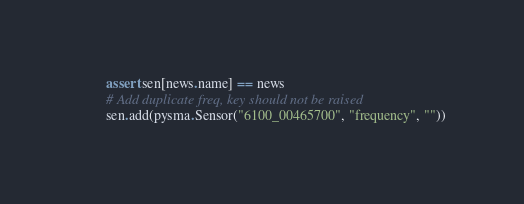Convert code to text. <code><loc_0><loc_0><loc_500><loc_500><_Python_>        assert sen[news.name] == news
        # Add duplicate freq, key should not be raised
        sen.add(pysma.Sensor("6100_00465700", "frequency", ""))</code> 